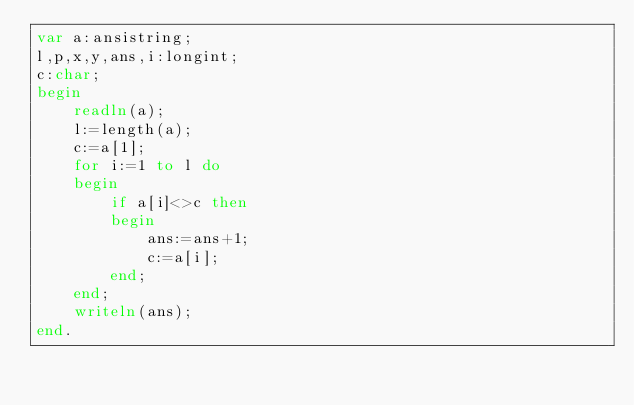<code> <loc_0><loc_0><loc_500><loc_500><_Pascal_>var a:ansistring;
l,p,x,y,ans,i:longint;
c:char;
begin
    readln(a);
    l:=length(a);
    c:=a[1];
    for i:=1 to l do
    begin
        if a[i]<>c then
        begin
            ans:=ans+1;
            c:=a[i];
        end;
    end;
    writeln(ans);
end.

</code> 